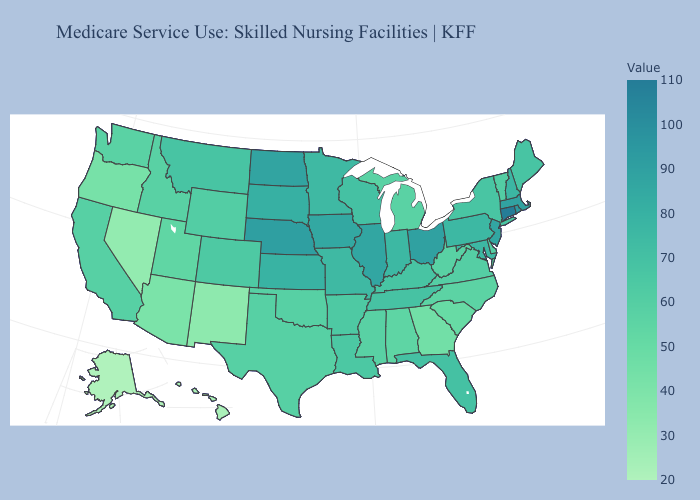Which states have the lowest value in the USA?
Give a very brief answer. Alaska. Which states have the highest value in the USA?
Keep it brief. Connecticut. Which states have the lowest value in the USA?
Short answer required. Alaska. 